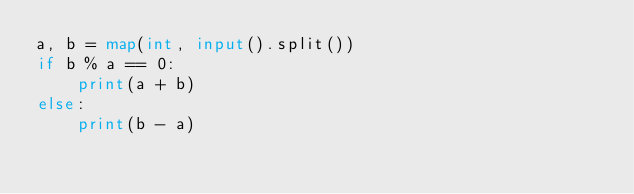<code> <loc_0><loc_0><loc_500><loc_500><_Python_>a, b = map(int, input().split())
if b % a == 0:
    print(a + b)
else:
    print(b - a)</code> 